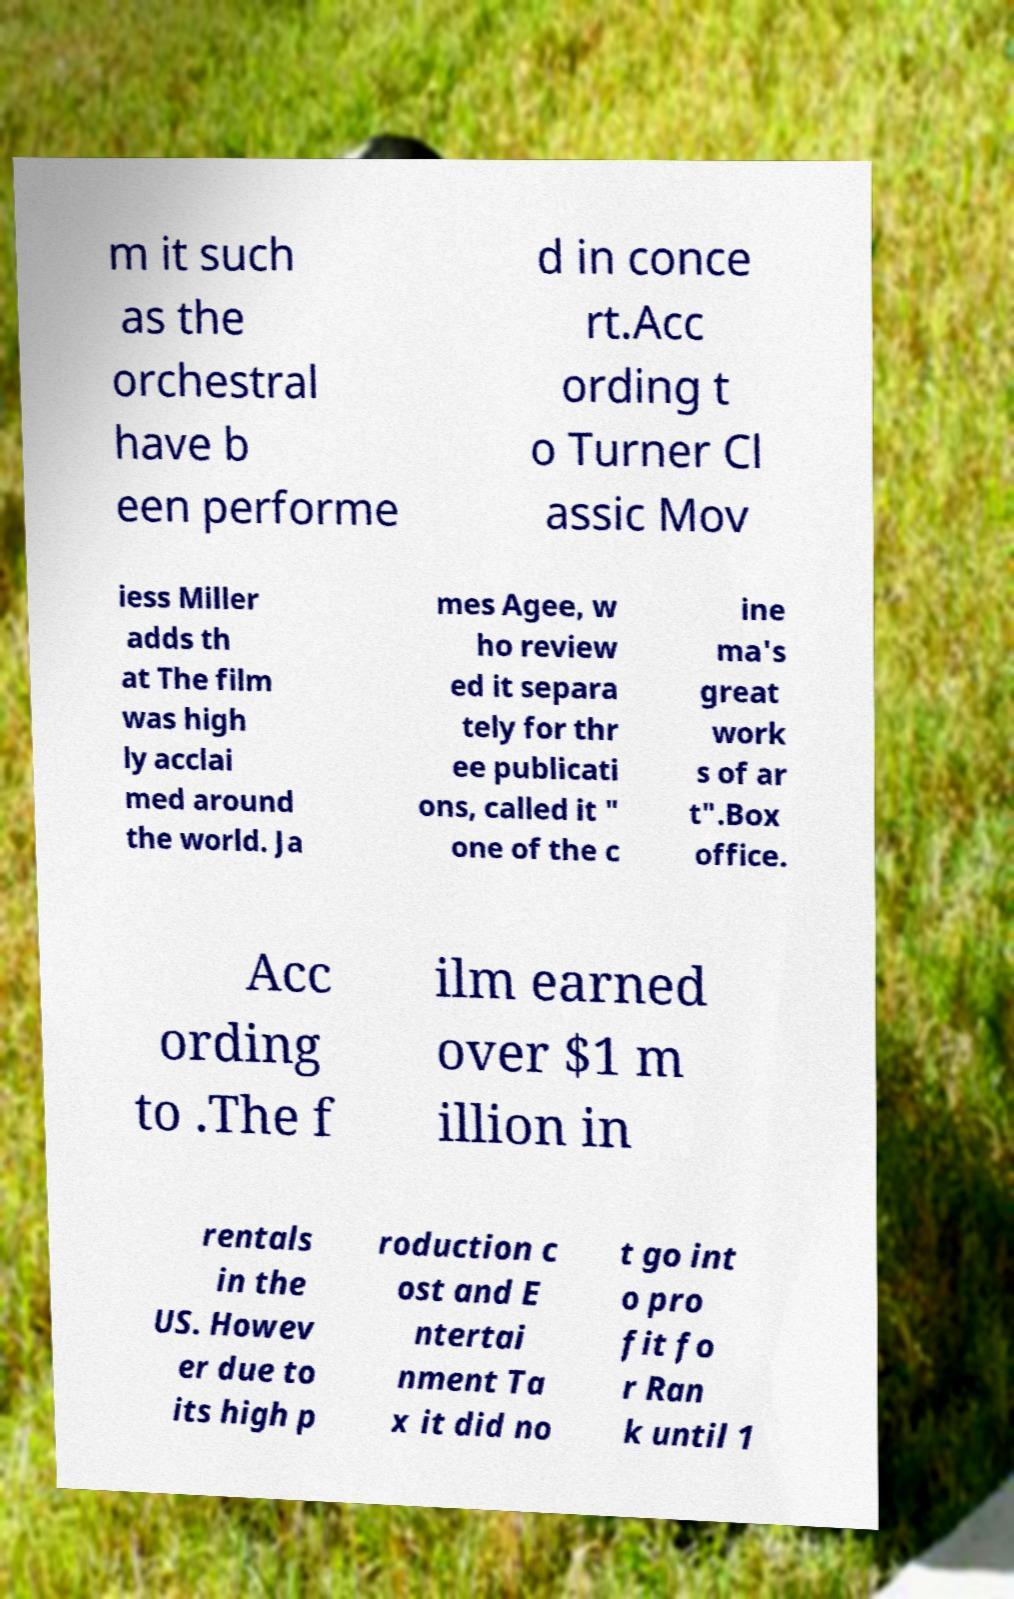What messages or text are displayed in this image? I need them in a readable, typed format. m it such as the orchestral have b een performe d in conce rt.Acc ording t o Turner Cl assic Mov iess Miller adds th at The film was high ly acclai med around the world. Ja mes Agee, w ho review ed it separa tely for thr ee publicati ons, called it " one of the c ine ma's great work s of ar t".Box office. Acc ording to .The f ilm earned over $1 m illion in rentals in the US. Howev er due to its high p roduction c ost and E ntertai nment Ta x it did no t go int o pro fit fo r Ran k until 1 